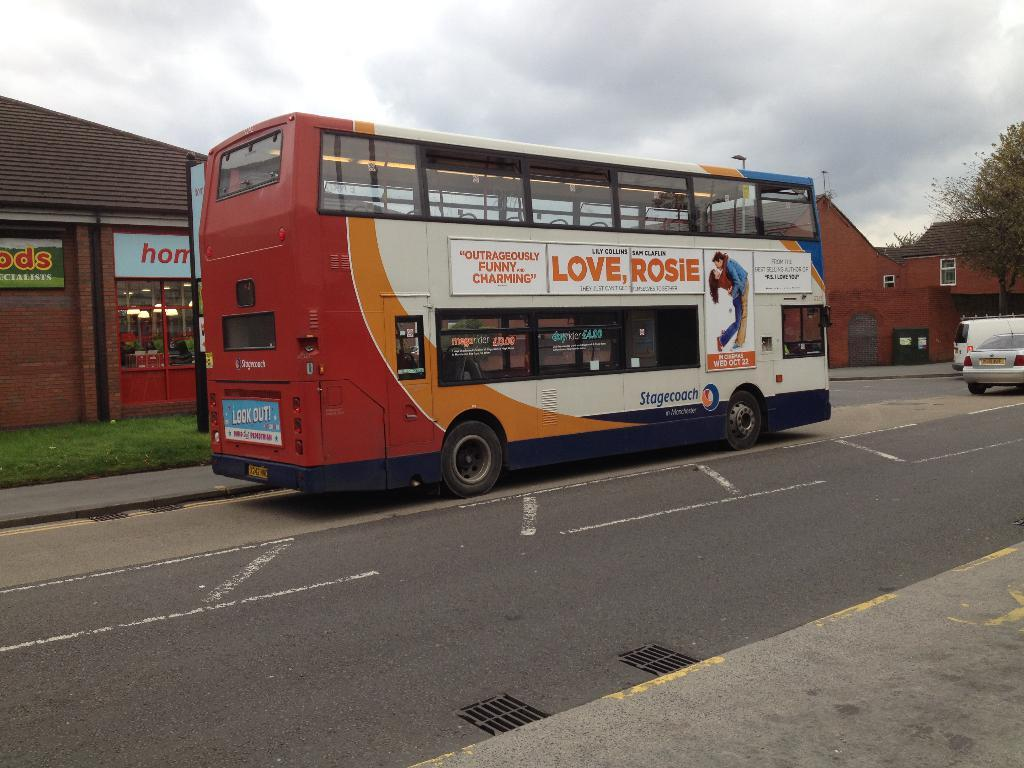<image>
Render a clear and concise summary of the photo. A double decker city bus with a sign on the side that says Love Rosie. 